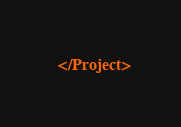<code> <loc_0><loc_0><loc_500><loc_500><_XML_>
</Project>
</code> 